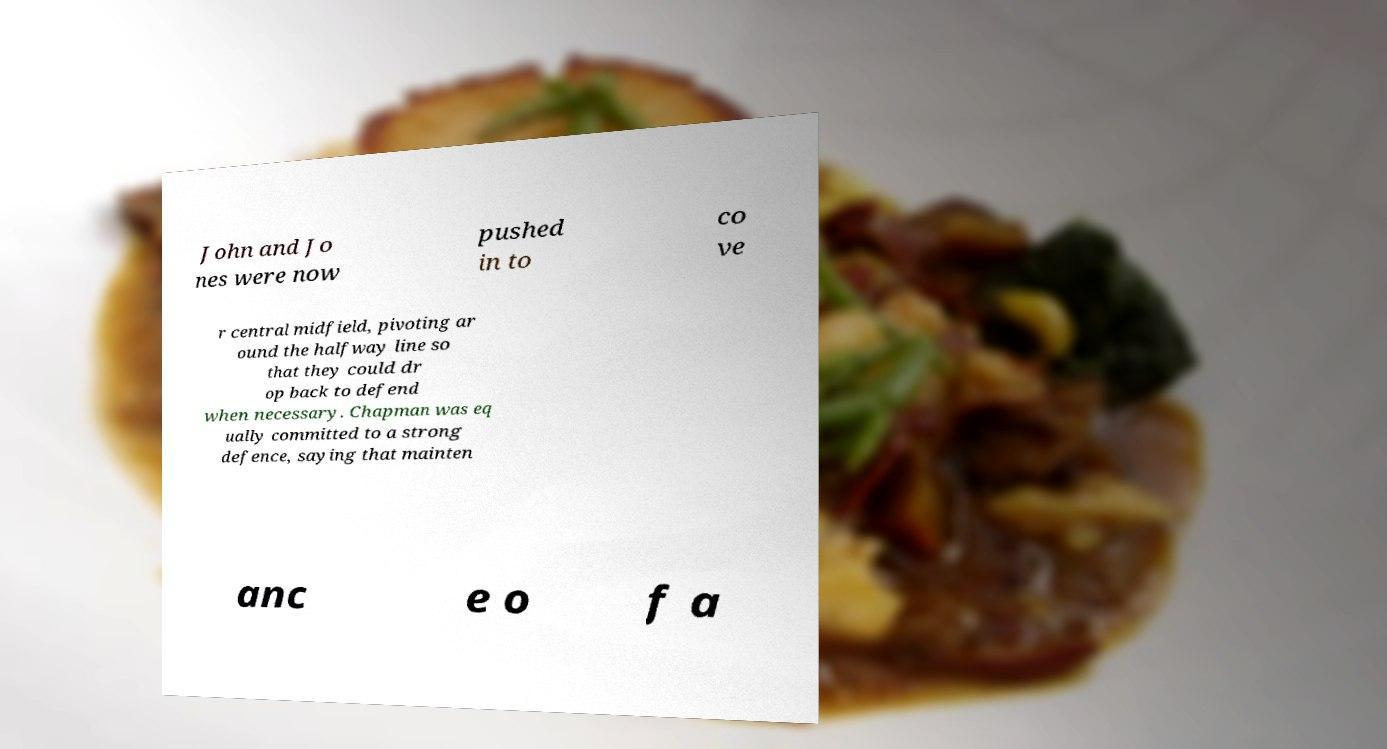For documentation purposes, I need the text within this image transcribed. Could you provide that? John and Jo nes were now pushed in to co ve r central midfield, pivoting ar ound the halfway line so that they could dr op back to defend when necessary. Chapman was eq ually committed to a strong defence, saying that mainten anc e o f a 